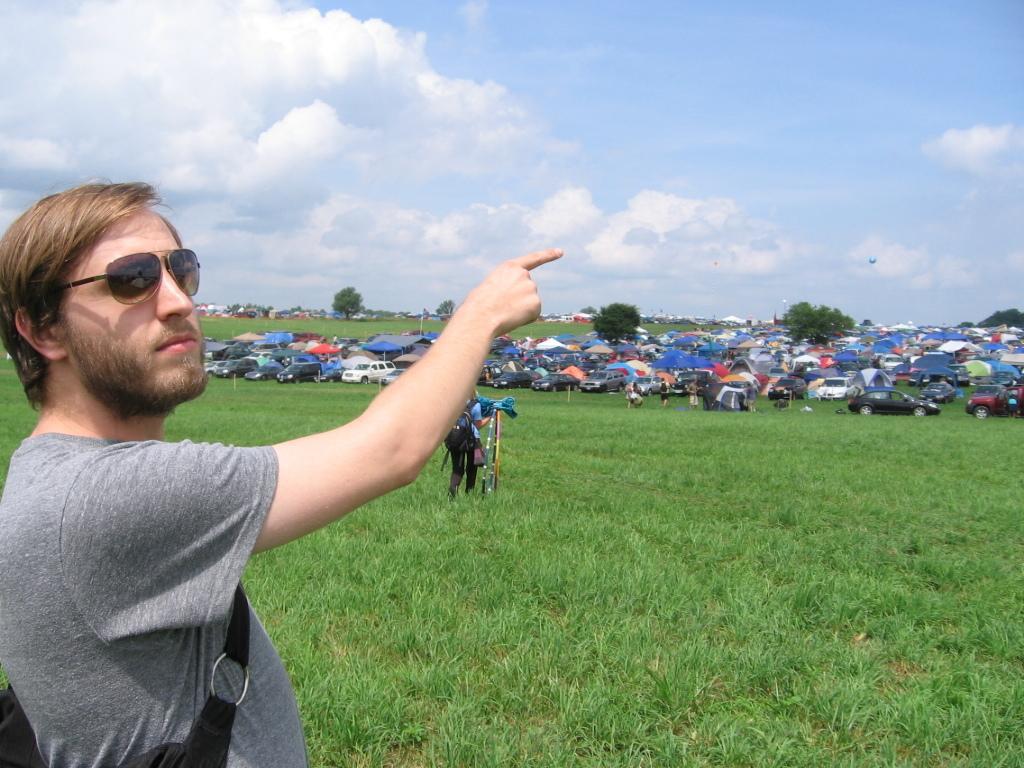Describe this image in one or two sentences. In this image there is a person standing on the surface of the grass and he is holding an object in his hand, at the center of the image there are few vehicles parked and there are few canopy's. In the background there are trees, buildings and the sky. 